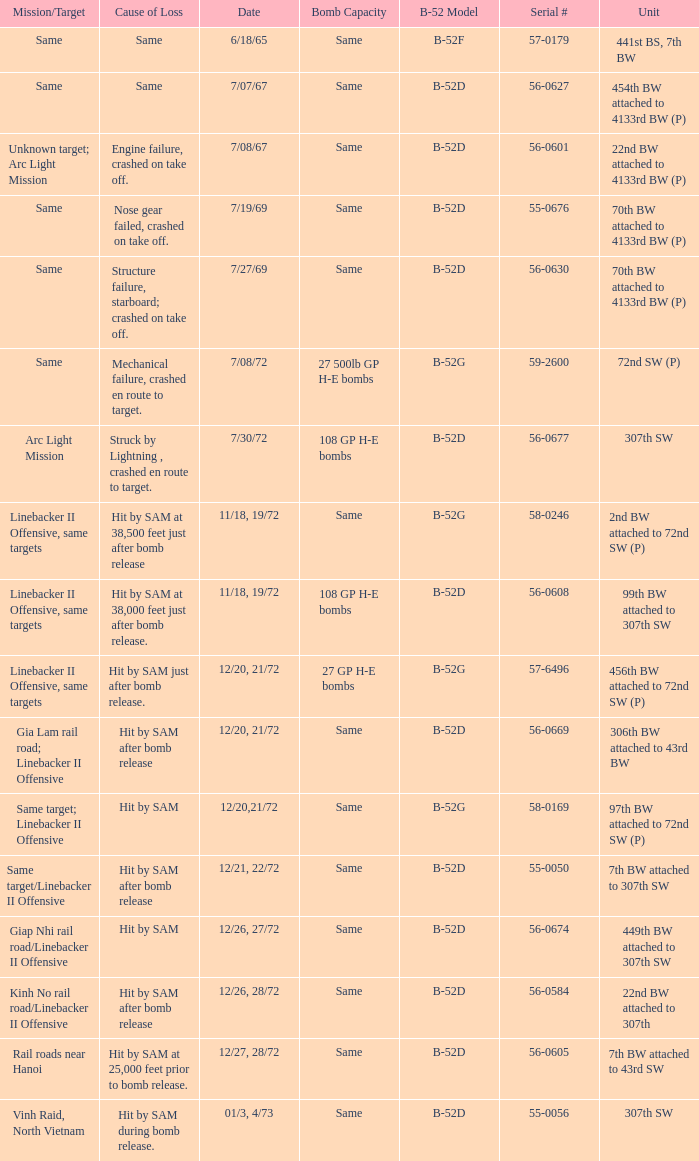When  same target; linebacker ii offensive is the same target what is the unit? 97th BW attached to 72nd SW (P). 